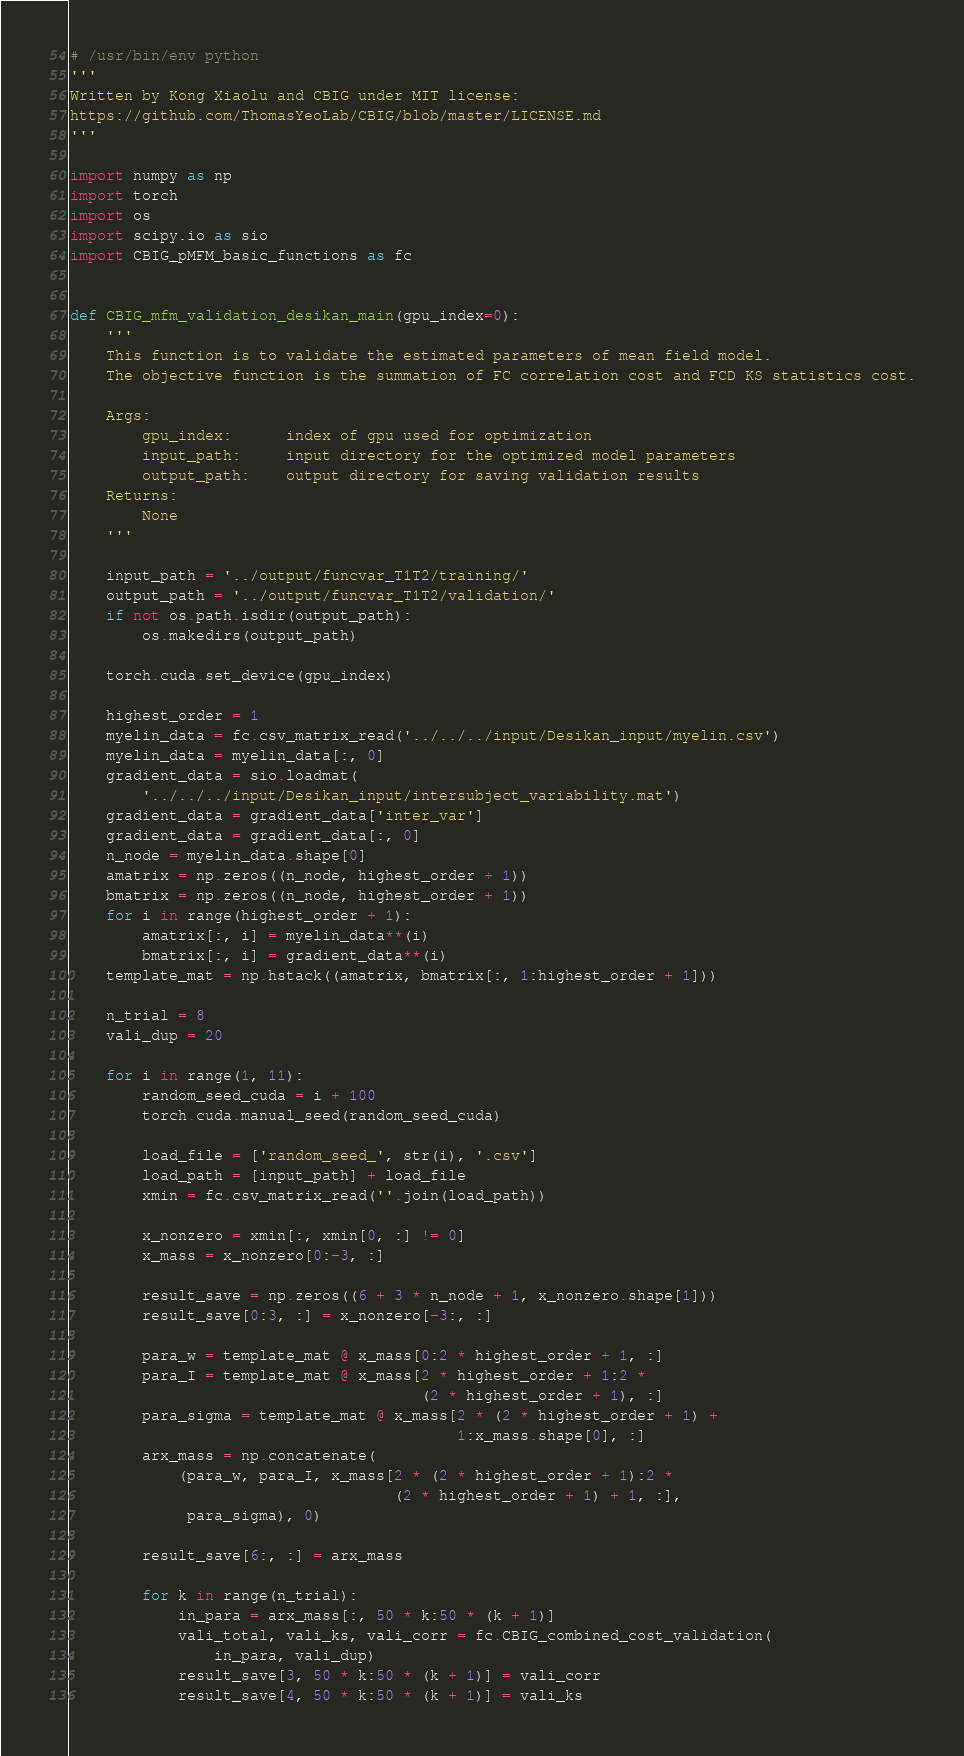Convert code to text. <code><loc_0><loc_0><loc_500><loc_500><_Python_># /usr/bin/env python
'''
Written by Kong Xiaolu and CBIG under MIT license:
https://github.com/ThomasYeoLab/CBIG/blob/master/LICENSE.md
'''

import numpy as np
import torch
import os
import scipy.io as sio
import CBIG_pMFM_basic_functions as fc


def CBIG_mfm_validation_desikan_main(gpu_index=0):
    '''
    This function is to validate the estimated parameters of mean field model.
    The objective function is the summation of FC correlation cost and FCD KS statistics cost.

    Args:
        gpu_index:      index of gpu used for optimization
        input_path:     input directory for the optimized model parameters
        output_path:    output directory for saving validation results
    Returns:
        None
    '''

    input_path = '../output/funcvar_T1T2/training/'
    output_path = '../output/funcvar_T1T2/validation/'
    if not os.path.isdir(output_path):
        os.makedirs(output_path)

    torch.cuda.set_device(gpu_index)

    highest_order = 1
    myelin_data = fc.csv_matrix_read('../../../input/Desikan_input/myelin.csv')
    myelin_data = myelin_data[:, 0]
    gradient_data = sio.loadmat(
        '../../../input/Desikan_input/intersubject_variability.mat')
    gradient_data = gradient_data['inter_var']
    gradient_data = gradient_data[:, 0]
    n_node = myelin_data.shape[0]
    amatrix = np.zeros((n_node, highest_order + 1))
    bmatrix = np.zeros((n_node, highest_order + 1))
    for i in range(highest_order + 1):
        amatrix[:, i] = myelin_data**(i)
        bmatrix[:, i] = gradient_data**(i)
    template_mat = np.hstack((amatrix, bmatrix[:, 1:highest_order + 1]))

    n_trial = 8
    vali_dup = 20

    for i in range(1, 11):
        random_seed_cuda = i + 100
        torch.cuda.manual_seed(random_seed_cuda)

        load_file = ['random_seed_', str(i), '.csv']
        load_path = [input_path] + load_file
        xmin = fc.csv_matrix_read(''.join(load_path))

        x_nonzero = xmin[:, xmin[0, :] != 0]
        x_mass = x_nonzero[0:-3, :]

        result_save = np.zeros((6 + 3 * n_node + 1, x_nonzero.shape[1]))
        result_save[0:3, :] = x_nonzero[-3:, :]

        para_w = template_mat @ x_mass[0:2 * highest_order + 1, :]
        para_I = template_mat @ x_mass[2 * highest_order + 1:2 *
                                       (2 * highest_order + 1), :]
        para_sigma = template_mat @ x_mass[2 * (2 * highest_order + 1) +
                                           1:x_mass.shape[0], :]
        arx_mass = np.concatenate(
            (para_w, para_I, x_mass[2 * (2 * highest_order + 1):2 *
                                    (2 * highest_order + 1) + 1, :],
             para_sigma), 0)

        result_save[6:, :] = arx_mass

        for k in range(n_trial):
            in_para = arx_mass[:, 50 * k:50 * (k + 1)]
            vali_total, vali_ks, vali_corr = fc.CBIG_combined_cost_validation(
                in_para, vali_dup)
            result_save[3, 50 * k:50 * (k + 1)] = vali_corr
            result_save[4, 50 * k:50 * (k + 1)] = vali_ks</code> 